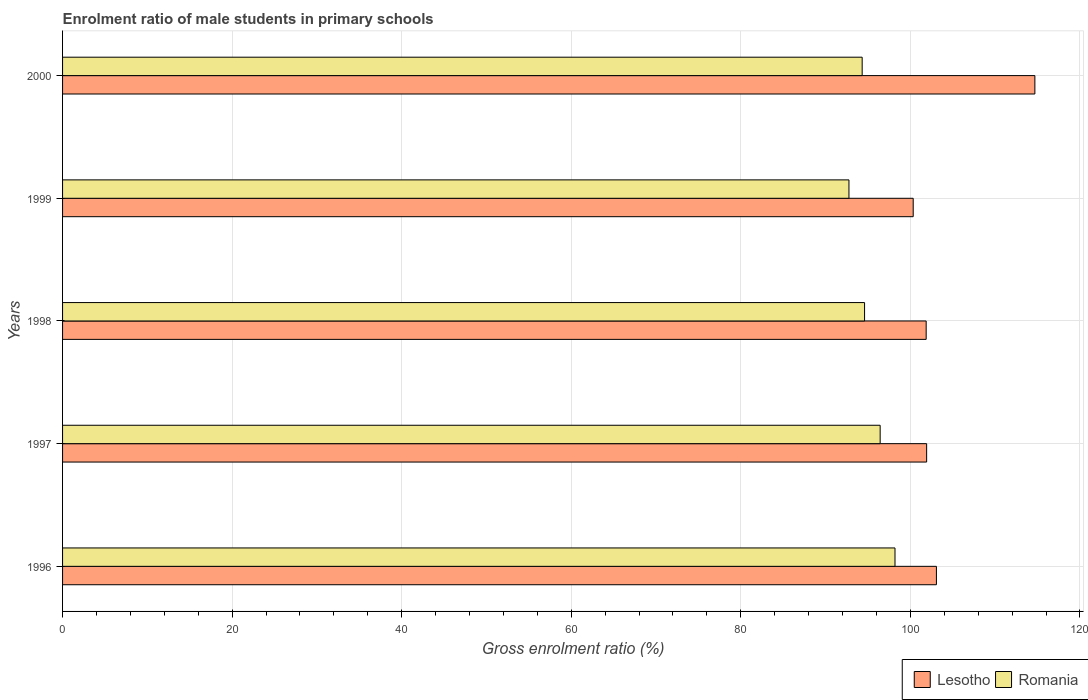How many different coloured bars are there?
Offer a terse response. 2. How many groups of bars are there?
Offer a terse response. 5. Are the number of bars per tick equal to the number of legend labels?
Make the answer very short. Yes. Are the number of bars on each tick of the Y-axis equal?
Provide a succinct answer. Yes. How many bars are there on the 2nd tick from the top?
Offer a terse response. 2. What is the label of the 3rd group of bars from the top?
Offer a terse response. 1998. In how many cases, is the number of bars for a given year not equal to the number of legend labels?
Ensure brevity in your answer.  0. What is the enrolment ratio of male students in primary schools in Lesotho in 1996?
Offer a very short reply. 103.07. Across all years, what is the maximum enrolment ratio of male students in primary schools in Lesotho?
Your answer should be compact. 114.68. Across all years, what is the minimum enrolment ratio of male students in primary schools in Lesotho?
Ensure brevity in your answer.  100.33. In which year was the enrolment ratio of male students in primary schools in Romania maximum?
Your answer should be compact. 1996. What is the total enrolment ratio of male students in primary schools in Romania in the graph?
Keep it short and to the point. 476.29. What is the difference between the enrolment ratio of male students in primary schools in Romania in 1998 and that in 1999?
Offer a terse response. 1.84. What is the difference between the enrolment ratio of male students in primary schools in Lesotho in 1996 and the enrolment ratio of male students in primary schools in Romania in 1997?
Offer a very short reply. 6.64. What is the average enrolment ratio of male students in primary schools in Lesotho per year?
Offer a very short reply. 104.37. In the year 1999, what is the difference between the enrolment ratio of male students in primary schools in Lesotho and enrolment ratio of male students in primary schools in Romania?
Provide a short and direct response. 7.58. What is the ratio of the enrolment ratio of male students in primary schools in Lesotho in 1996 to that in 2000?
Give a very brief answer. 0.9. Is the enrolment ratio of male students in primary schools in Lesotho in 1998 less than that in 2000?
Provide a short and direct response. Yes. Is the difference between the enrolment ratio of male students in primary schools in Lesotho in 1996 and 1997 greater than the difference between the enrolment ratio of male students in primary schools in Romania in 1996 and 1997?
Provide a short and direct response. No. What is the difference between the highest and the second highest enrolment ratio of male students in primary schools in Lesotho?
Your answer should be compact. 11.61. What is the difference between the highest and the lowest enrolment ratio of male students in primary schools in Romania?
Provide a succinct answer. 5.43. Is the sum of the enrolment ratio of male students in primary schools in Lesotho in 1998 and 1999 greater than the maximum enrolment ratio of male students in primary schools in Romania across all years?
Your answer should be very brief. Yes. What does the 2nd bar from the top in 1996 represents?
Make the answer very short. Lesotho. What does the 2nd bar from the bottom in 2000 represents?
Make the answer very short. Romania. How many bars are there?
Provide a short and direct response. 10. What is the difference between two consecutive major ticks on the X-axis?
Make the answer very short. 20. Does the graph contain any zero values?
Provide a succinct answer. No. What is the title of the graph?
Provide a short and direct response. Enrolment ratio of male students in primary schools. What is the Gross enrolment ratio (%) in Lesotho in 1996?
Your answer should be very brief. 103.07. What is the Gross enrolment ratio (%) in Romania in 1996?
Ensure brevity in your answer.  98.19. What is the Gross enrolment ratio (%) of Lesotho in 1997?
Provide a short and direct response. 101.92. What is the Gross enrolment ratio (%) of Romania in 1997?
Make the answer very short. 96.44. What is the Gross enrolment ratio (%) in Lesotho in 1998?
Offer a very short reply. 101.86. What is the Gross enrolment ratio (%) in Romania in 1998?
Your answer should be compact. 94.6. What is the Gross enrolment ratio (%) of Lesotho in 1999?
Offer a terse response. 100.33. What is the Gross enrolment ratio (%) of Romania in 1999?
Your answer should be very brief. 92.75. What is the Gross enrolment ratio (%) of Lesotho in 2000?
Your answer should be very brief. 114.68. What is the Gross enrolment ratio (%) of Romania in 2000?
Your response must be concise. 94.31. Across all years, what is the maximum Gross enrolment ratio (%) in Lesotho?
Make the answer very short. 114.68. Across all years, what is the maximum Gross enrolment ratio (%) in Romania?
Make the answer very short. 98.19. Across all years, what is the minimum Gross enrolment ratio (%) of Lesotho?
Ensure brevity in your answer.  100.33. Across all years, what is the minimum Gross enrolment ratio (%) of Romania?
Your answer should be compact. 92.75. What is the total Gross enrolment ratio (%) in Lesotho in the graph?
Offer a terse response. 521.87. What is the total Gross enrolment ratio (%) of Romania in the graph?
Give a very brief answer. 476.29. What is the difference between the Gross enrolment ratio (%) of Lesotho in 1996 and that in 1997?
Provide a succinct answer. 1.15. What is the difference between the Gross enrolment ratio (%) in Romania in 1996 and that in 1997?
Provide a short and direct response. 1.75. What is the difference between the Gross enrolment ratio (%) in Lesotho in 1996 and that in 1998?
Your response must be concise. 1.21. What is the difference between the Gross enrolment ratio (%) of Romania in 1996 and that in 1998?
Offer a very short reply. 3.59. What is the difference between the Gross enrolment ratio (%) in Lesotho in 1996 and that in 1999?
Give a very brief answer. 2.74. What is the difference between the Gross enrolment ratio (%) of Romania in 1996 and that in 1999?
Your answer should be compact. 5.43. What is the difference between the Gross enrolment ratio (%) in Lesotho in 1996 and that in 2000?
Ensure brevity in your answer.  -11.61. What is the difference between the Gross enrolment ratio (%) in Romania in 1996 and that in 2000?
Provide a succinct answer. 3.87. What is the difference between the Gross enrolment ratio (%) in Lesotho in 1997 and that in 1998?
Your answer should be compact. 0.05. What is the difference between the Gross enrolment ratio (%) in Romania in 1997 and that in 1998?
Give a very brief answer. 1.84. What is the difference between the Gross enrolment ratio (%) in Lesotho in 1997 and that in 1999?
Keep it short and to the point. 1.58. What is the difference between the Gross enrolment ratio (%) in Romania in 1997 and that in 1999?
Provide a short and direct response. 3.68. What is the difference between the Gross enrolment ratio (%) of Lesotho in 1997 and that in 2000?
Your answer should be compact. -12.77. What is the difference between the Gross enrolment ratio (%) of Romania in 1997 and that in 2000?
Make the answer very short. 2.12. What is the difference between the Gross enrolment ratio (%) in Lesotho in 1998 and that in 1999?
Your response must be concise. 1.53. What is the difference between the Gross enrolment ratio (%) of Romania in 1998 and that in 1999?
Give a very brief answer. 1.84. What is the difference between the Gross enrolment ratio (%) of Lesotho in 1998 and that in 2000?
Keep it short and to the point. -12.82. What is the difference between the Gross enrolment ratio (%) in Romania in 1998 and that in 2000?
Make the answer very short. 0.28. What is the difference between the Gross enrolment ratio (%) of Lesotho in 1999 and that in 2000?
Ensure brevity in your answer.  -14.35. What is the difference between the Gross enrolment ratio (%) in Romania in 1999 and that in 2000?
Keep it short and to the point. -1.56. What is the difference between the Gross enrolment ratio (%) in Lesotho in 1996 and the Gross enrolment ratio (%) in Romania in 1997?
Give a very brief answer. 6.64. What is the difference between the Gross enrolment ratio (%) in Lesotho in 1996 and the Gross enrolment ratio (%) in Romania in 1998?
Provide a short and direct response. 8.48. What is the difference between the Gross enrolment ratio (%) in Lesotho in 1996 and the Gross enrolment ratio (%) in Romania in 1999?
Make the answer very short. 10.32. What is the difference between the Gross enrolment ratio (%) in Lesotho in 1996 and the Gross enrolment ratio (%) in Romania in 2000?
Give a very brief answer. 8.76. What is the difference between the Gross enrolment ratio (%) in Lesotho in 1997 and the Gross enrolment ratio (%) in Romania in 1998?
Give a very brief answer. 7.32. What is the difference between the Gross enrolment ratio (%) in Lesotho in 1997 and the Gross enrolment ratio (%) in Romania in 1999?
Provide a short and direct response. 9.16. What is the difference between the Gross enrolment ratio (%) of Lesotho in 1997 and the Gross enrolment ratio (%) of Romania in 2000?
Your answer should be compact. 7.6. What is the difference between the Gross enrolment ratio (%) in Lesotho in 1998 and the Gross enrolment ratio (%) in Romania in 1999?
Your answer should be very brief. 9.11. What is the difference between the Gross enrolment ratio (%) of Lesotho in 1998 and the Gross enrolment ratio (%) of Romania in 2000?
Provide a short and direct response. 7.55. What is the difference between the Gross enrolment ratio (%) in Lesotho in 1999 and the Gross enrolment ratio (%) in Romania in 2000?
Provide a short and direct response. 6.02. What is the average Gross enrolment ratio (%) of Lesotho per year?
Your response must be concise. 104.37. What is the average Gross enrolment ratio (%) of Romania per year?
Ensure brevity in your answer.  95.26. In the year 1996, what is the difference between the Gross enrolment ratio (%) in Lesotho and Gross enrolment ratio (%) in Romania?
Ensure brevity in your answer.  4.89. In the year 1997, what is the difference between the Gross enrolment ratio (%) of Lesotho and Gross enrolment ratio (%) of Romania?
Keep it short and to the point. 5.48. In the year 1998, what is the difference between the Gross enrolment ratio (%) in Lesotho and Gross enrolment ratio (%) in Romania?
Give a very brief answer. 7.27. In the year 1999, what is the difference between the Gross enrolment ratio (%) of Lesotho and Gross enrolment ratio (%) of Romania?
Give a very brief answer. 7.58. In the year 2000, what is the difference between the Gross enrolment ratio (%) in Lesotho and Gross enrolment ratio (%) in Romania?
Offer a terse response. 20.37. What is the ratio of the Gross enrolment ratio (%) of Lesotho in 1996 to that in 1997?
Make the answer very short. 1.01. What is the ratio of the Gross enrolment ratio (%) of Romania in 1996 to that in 1997?
Your response must be concise. 1.02. What is the ratio of the Gross enrolment ratio (%) in Lesotho in 1996 to that in 1998?
Offer a very short reply. 1.01. What is the ratio of the Gross enrolment ratio (%) of Romania in 1996 to that in 1998?
Keep it short and to the point. 1.04. What is the ratio of the Gross enrolment ratio (%) of Lesotho in 1996 to that in 1999?
Your response must be concise. 1.03. What is the ratio of the Gross enrolment ratio (%) of Romania in 1996 to that in 1999?
Make the answer very short. 1.06. What is the ratio of the Gross enrolment ratio (%) of Lesotho in 1996 to that in 2000?
Make the answer very short. 0.9. What is the ratio of the Gross enrolment ratio (%) in Romania in 1996 to that in 2000?
Your answer should be very brief. 1.04. What is the ratio of the Gross enrolment ratio (%) in Romania in 1997 to that in 1998?
Provide a succinct answer. 1.02. What is the ratio of the Gross enrolment ratio (%) of Lesotho in 1997 to that in 1999?
Offer a terse response. 1.02. What is the ratio of the Gross enrolment ratio (%) of Romania in 1997 to that in 1999?
Your answer should be compact. 1.04. What is the ratio of the Gross enrolment ratio (%) in Lesotho in 1997 to that in 2000?
Offer a terse response. 0.89. What is the ratio of the Gross enrolment ratio (%) in Romania in 1997 to that in 2000?
Give a very brief answer. 1.02. What is the ratio of the Gross enrolment ratio (%) of Lesotho in 1998 to that in 1999?
Keep it short and to the point. 1.02. What is the ratio of the Gross enrolment ratio (%) of Romania in 1998 to that in 1999?
Make the answer very short. 1.02. What is the ratio of the Gross enrolment ratio (%) in Lesotho in 1998 to that in 2000?
Make the answer very short. 0.89. What is the ratio of the Gross enrolment ratio (%) in Lesotho in 1999 to that in 2000?
Provide a succinct answer. 0.87. What is the ratio of the Gross enrolment ratio (%) in Romania in 1999 to that in 2000?
Keep it short and to the point. 0.98. What is the difference between the highest and the second highest Gross enrolment ratio (%) of Lesotho?
Make the answer very short. 11.61. What is the difference between the highest and the second highest Gross enrolment ratio (%) in Romania?
Give a very brief answer. 1.75. What is the difference between the highest and the lowest Gross enrolment ratio (%) of Lesotho?
Your response must be concise. 14.35. What is the difference between the highest and the lowest Gross enrolment ratio (%) in Romania?
Offer a very short reply. 5.43. 